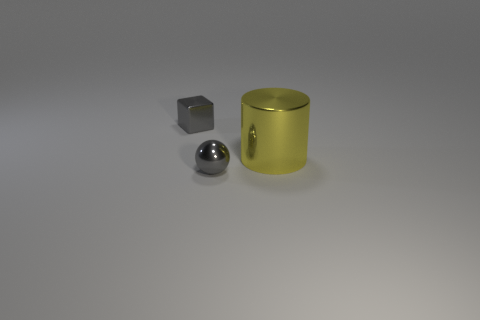Add 2 shiny cylinders. How many objects exist? 5 Add 3 large cyan rubber cylinders. How many large cyan rubber cylinders exist? 3 Subtract 1 gray spheres. How many objects are left? 2 Subtract all cylinders. How many objects are left? 2 Subtract 1 spheres. How many spheres are left? 0 Subtract all cyan cylinders. Subtract all cyan spheres. How many cylinders are left? 1 Subtract all cyan metal balls. Subtract all tiny objects. How many objects are left? 1 Add 3 tiny gray metal objects. How many tiny gray metal objects are left? 5 